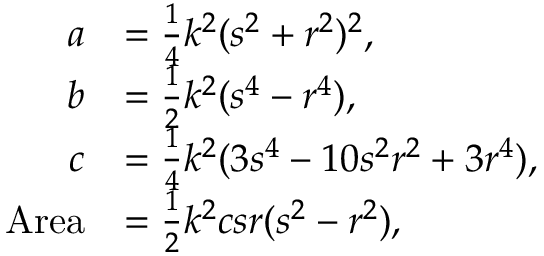<formula> <loc_0><loc_0><loc_500><loc_500>{ \begin{array} { r l } { a } & { = { \frac { 1 } { 4 } } k ^ { 2 } ( s ^ { 2 } + r ^ { 2 } ) ^ { 2 } , } \\ { b } & { = { \frac { 1 } { 2 } } k ^ { 2 } ( s ^ { 4 } - r ^ { 4 } ) , } \\ { c } & { = { \frac { 1 } { 4 } } k ^ { 2 } ( 3 s ^ { 4 } - 1 0 s ^ { 2 } r ^ { 2 } + 3 r ^ { 4 } ) , } \\ { A r e a } & { = { \frac { 1 } { 2 } } k ^ { 2 } c s r ( s ^ { 2 } - r ^ { 2 } ) , } \end{array} }</formula> 